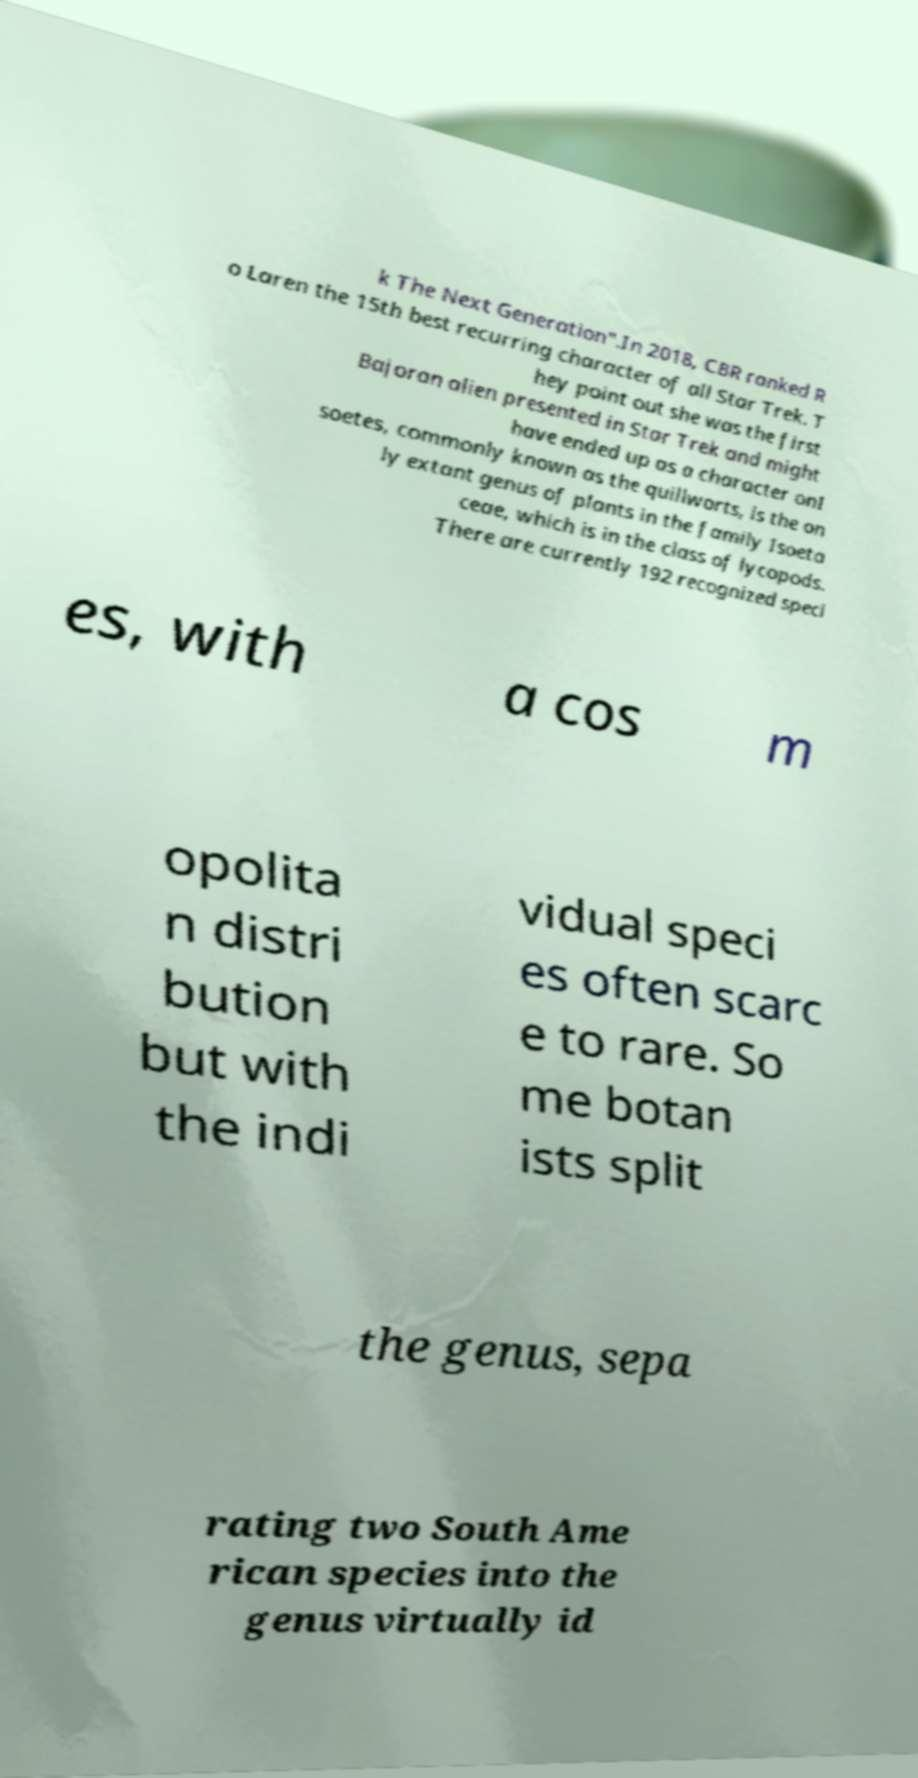I need the written content from this picture converted into text. Can you do that? k The Next Generation".In 2018, CBR ranked R o Laren the 15th best recurring character of all Star Trek. T hey point out she was the first Bajoran alien presented in Star Trek and might have ended up as a character onI soetes, commonly known as the quillworts, is the on ly extant genus of plants in the family Isoeta ceae, which is in the class of lycopods. There are currently 192 recognized speci es, with a cos m opolita n distri bution but with the indi vidual speci es often scarc e to rare. So me botan ists split the genus, sepa rating two South Ame rican species into the genus virtually id 